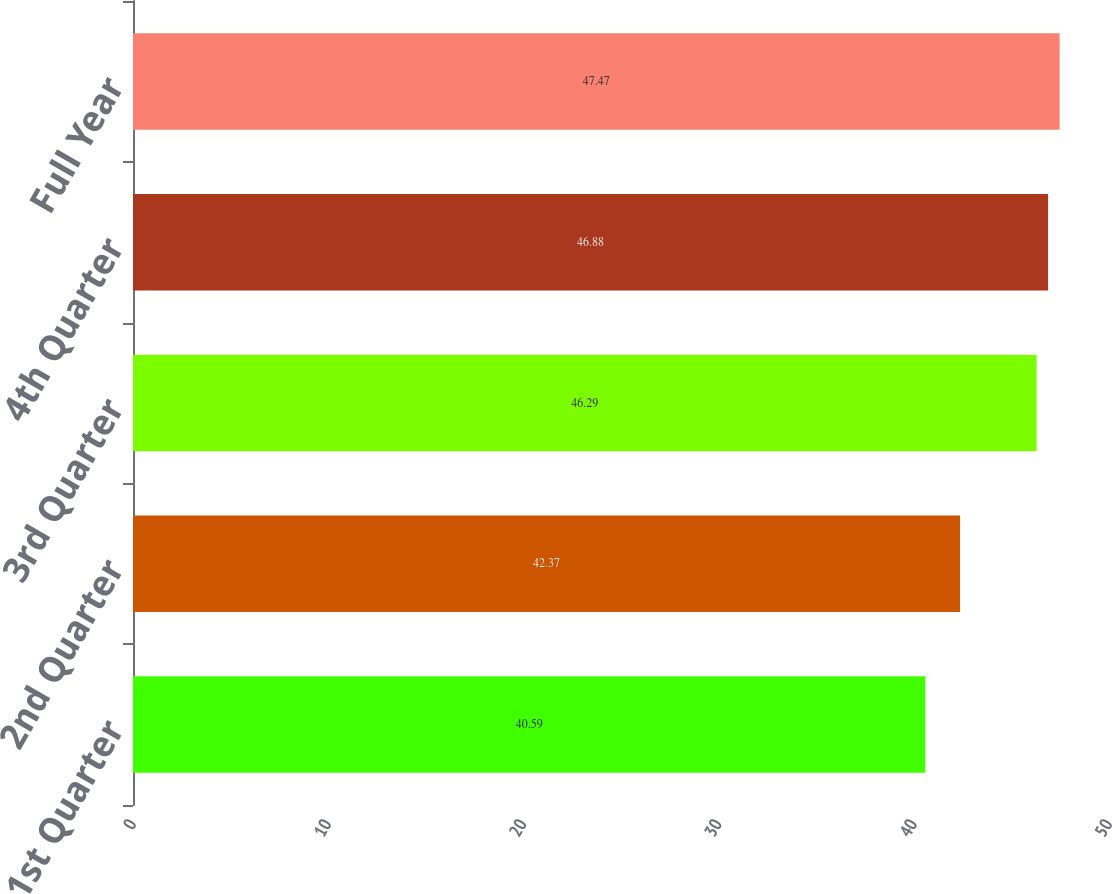Convert chart to OTSL. <chart><loc_0><loc_0><loc_500><loc_500><bar_chart><fcel>1st Quarter<fcel>2nd Quarter<fcel>3rd Quarter<fcel>4th Quarter<fcel>Full Year<nl><fcel>40.59<fcel>42.37<fcel>46.29<fcel>46.88<fcel>47.47<nl></chart> 